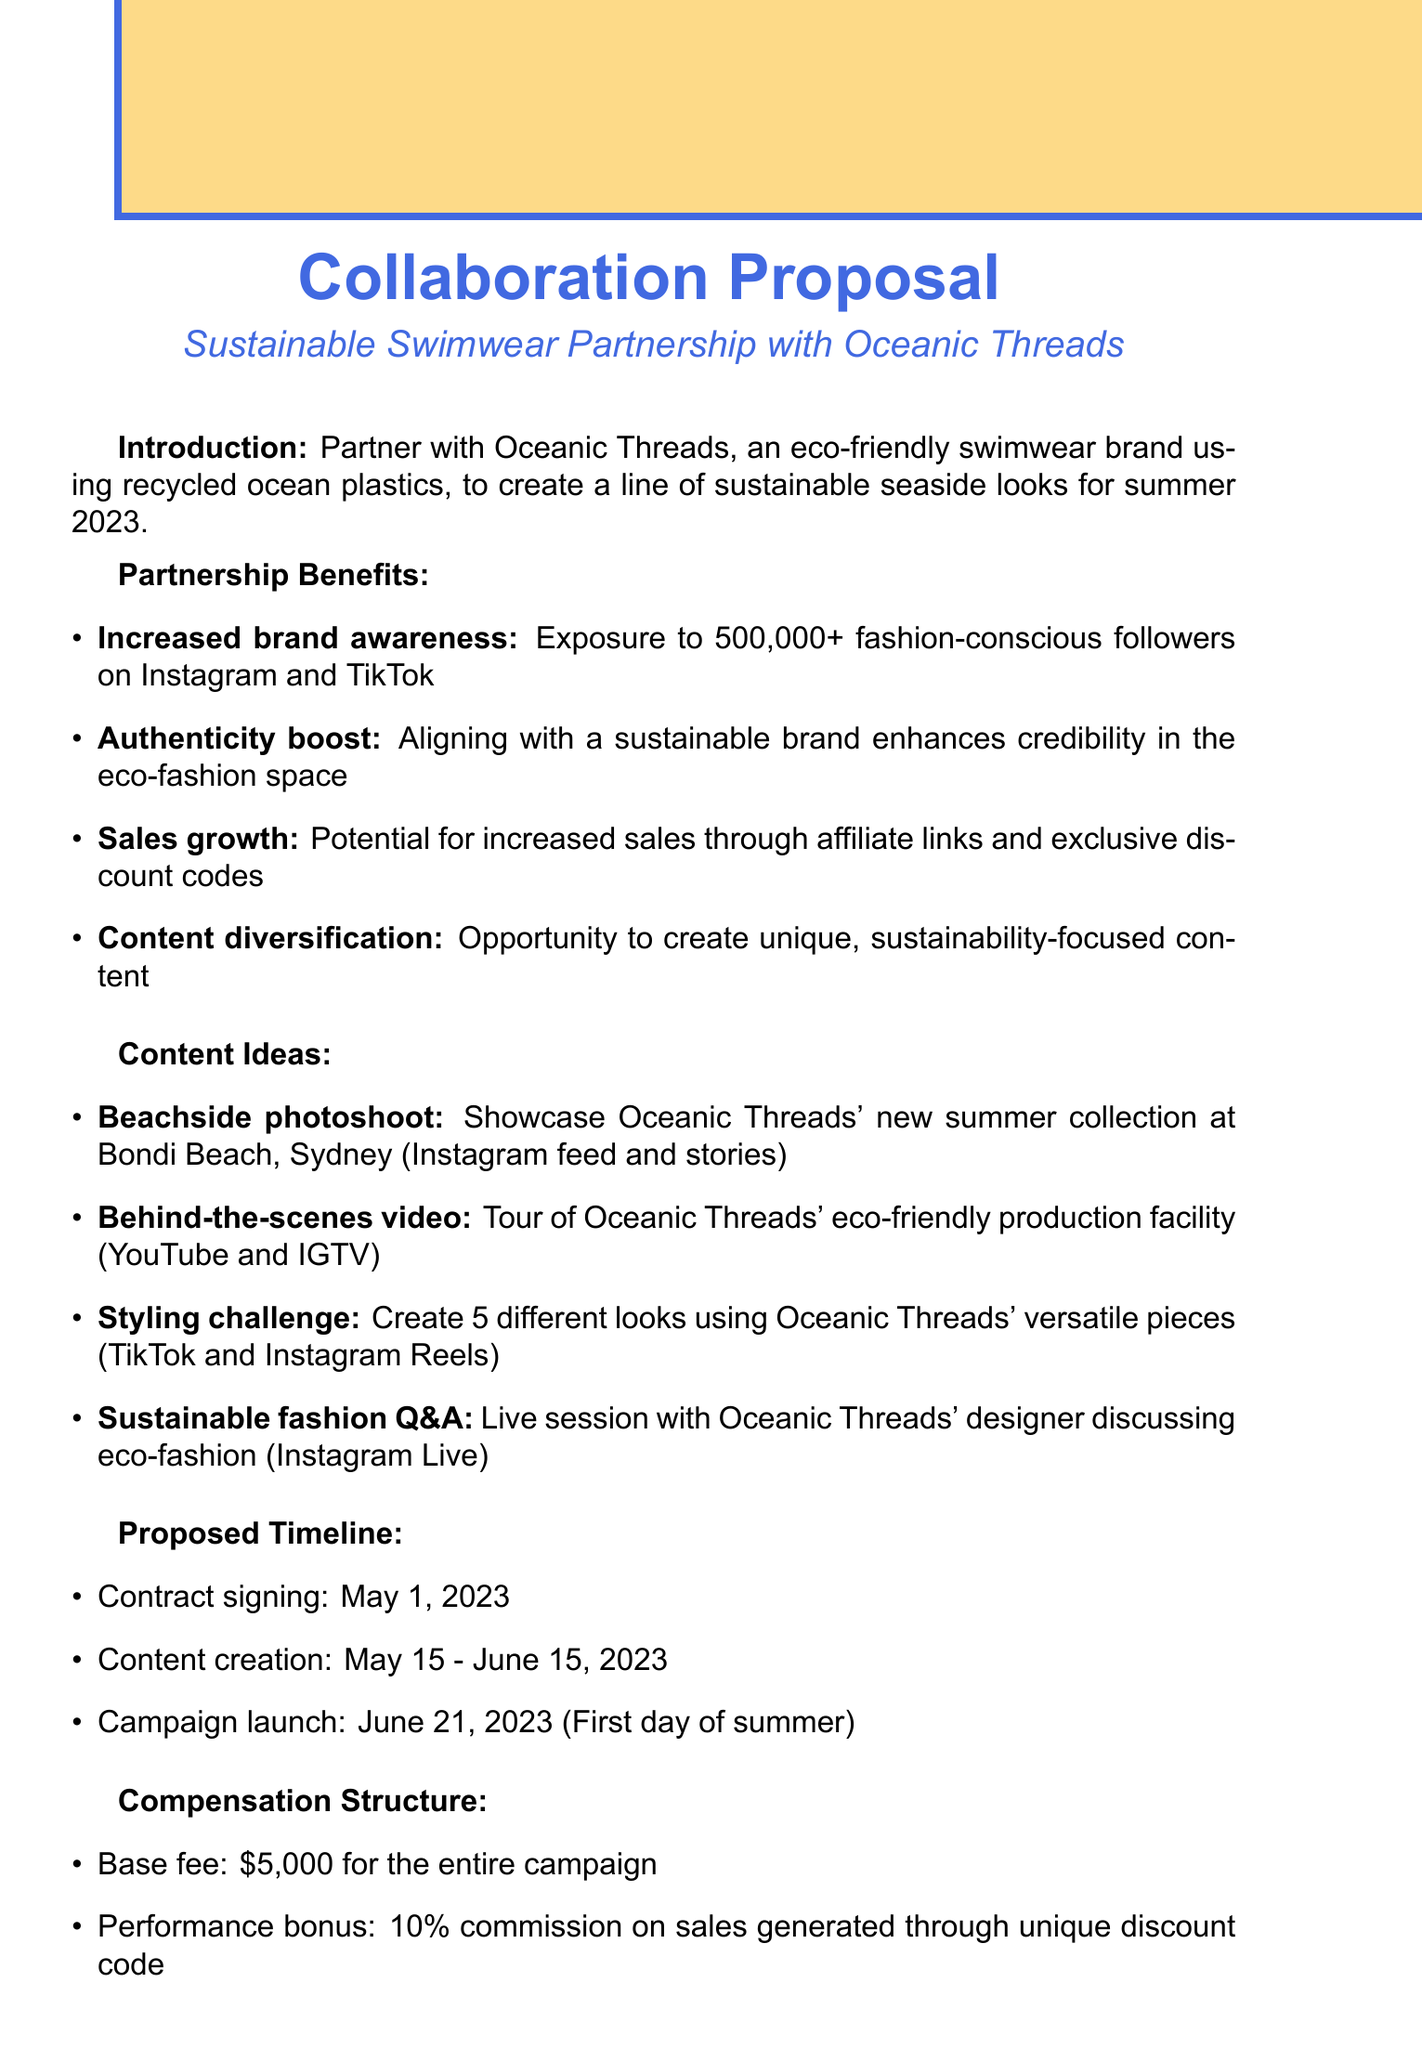what is the brand name proposed for the collaboration? The brand name proposed for the collaboration is mentioned in the introduction section of the document.
Answer: Oceanic Threads what is the goal of the collaboration? The goal of the collaboration is outlined in the introduction section.
Answer: Create a line of sustainable seaside looks for summer 2023 how many followers will be exposed to the collaboration? The number of followers mentioned for exposure in the partnership benefits section.
Answer: 500,000+ what is the base fee for the campaign? The base fee is specified in the compensation structure section of the document.
Answer: $5,000 when is the campaign launch date? The campaign launch date is included in the proposed timeline section.
Answer: June 21, 2023 what type of video is suggested as content? This content idea can be found in the content ideas section of the document.
Answer: Behind-the-scenes video what is the performance bonus percentage? The performance bonus percentage is stated in the compensation structure section.
Answer: 10% what platform is suggested for the styling challenge? The platform for the styling challenge is detailed in the content ideas section of the document.
Answer: TikTok and Instagram Reels what is the first step in the next steps section? The first step in the next steps section is explicitly listed in the document.
Answer: Review and discuss proposal 